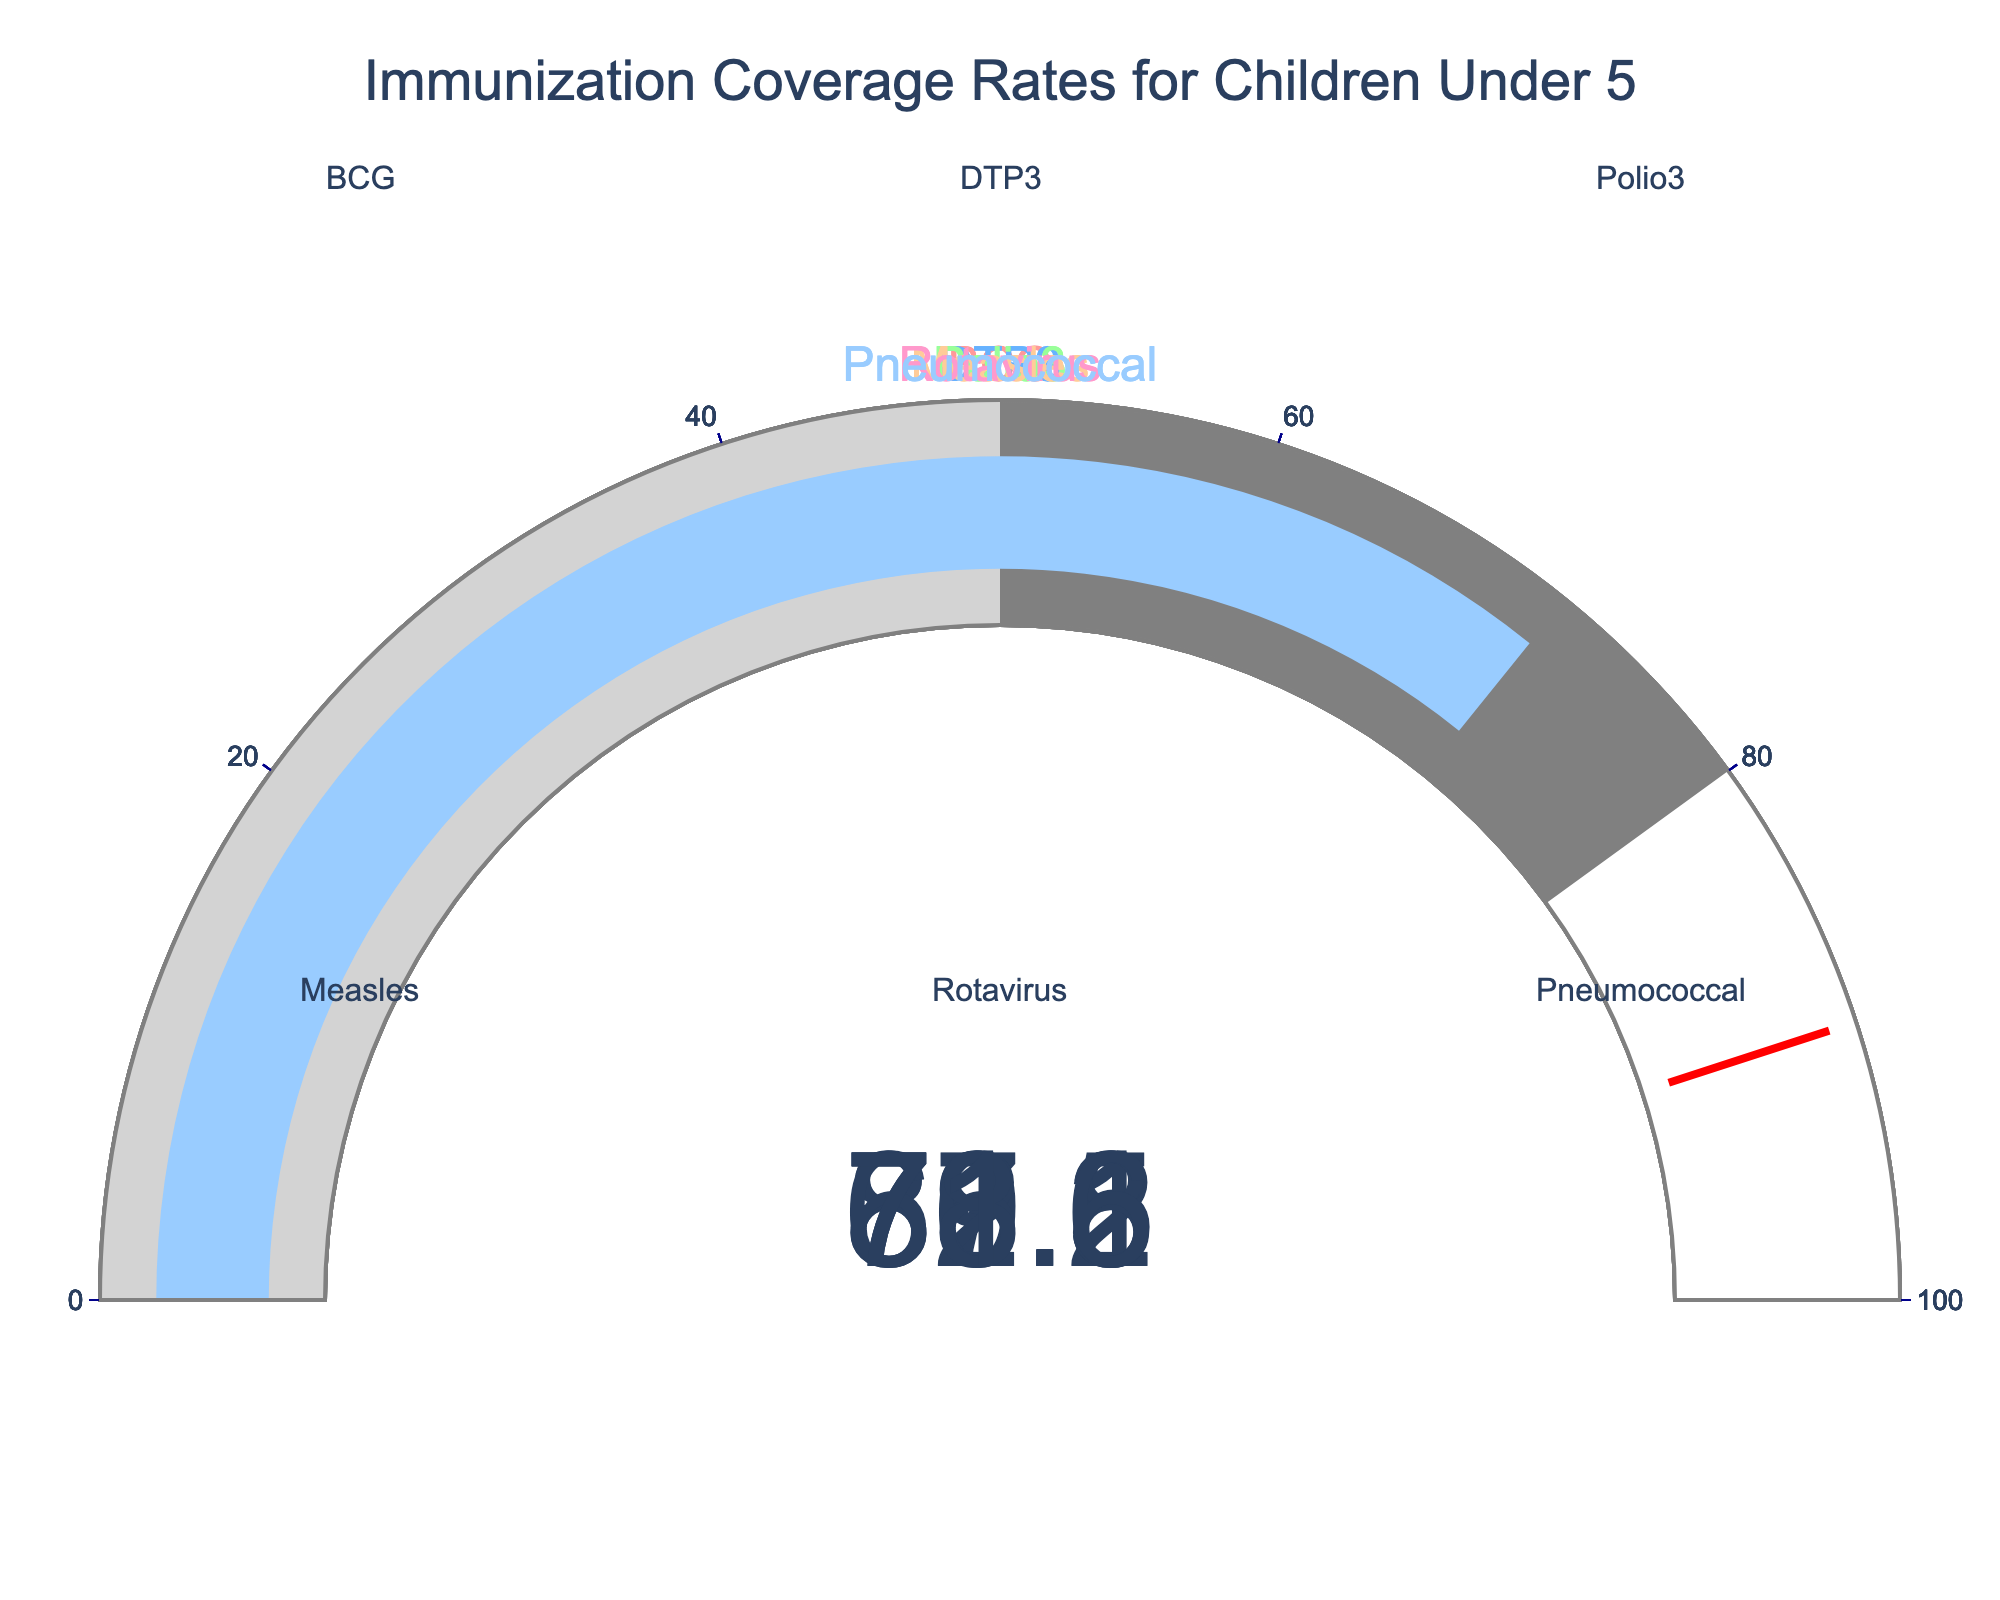What is the title of the figure? The title of the figure is displayed prominently at the top, indicating the focus of the chart. The text reads "Immunization Coverage Rates for Children Under 5".
Answer: "Immunization Coverage Rates for Children Under 5" Which vaccine has the highest coverage rate? By examining each gauge, we can identify that BCG has the highest coverage rate, which is highlighted by the number displayed on its gauge.
Answer: BCG What is the coverage rate for the Measles vaccine? The number displayed on the gauge corresponding to Measles indicates its coverage rate. It shows 76.8.
Answer: 76.8 How many vaccines have a coverage rate above 80%? Look at each gauge and count those with values exceeding 80%. BCG, DTP3, and Polio3 have coverage rates above 80%.
Answer: 3 Which vaccine has the lowest coverage rate? By comparing the numbers on all gauges, the Rotavirus vaccine has the lowest rate, shown by its gauge reading 68.3.
Answer: Rotavirus What is the average coverage rate of all vaccines? Sum the coverage rates: 87.5 (BCG) + 79.2 (DTP3) + 82.1 (Polio3) + 76.8 (Measles) + 68.3 (Rotavirus) + 71.6 (Pneumococcal) = 465.5. Then divide by the number of vaccines (6): 465.5 / 6 = 77.58.
Answer: 77.58 What is the difference in coverage rates between the vaccine with the lowest and highest rates? Subtract the lowest rate (Rotavirus: 68.3) from the highest rate (BCG: 87.5): 87.5 - 68.3 = 19.2.
Answer: 19.2 Which vaccines have coverage rates between 70% and 80%? Identify the gauges with values in the range 70 to 80. These are Pneumococcal, DTP3, and Measles.
Answer: Pneumococcal, DTP3, Measles What is the median coverage rate of the vaccines? List the coverage rates in ascending order: 68.3, 71.6, 76.8, 79.2, 82.1, 87.5. The median is the average of the middle two values: (76.8 + 79.2) / 2 = 78.
Answer: 78 What threshold value is indicated on each gauge? The threshold line on each gauge is set at 90, indicated by a red line. This threshold universally applies to all gauges.
Answer: 90 